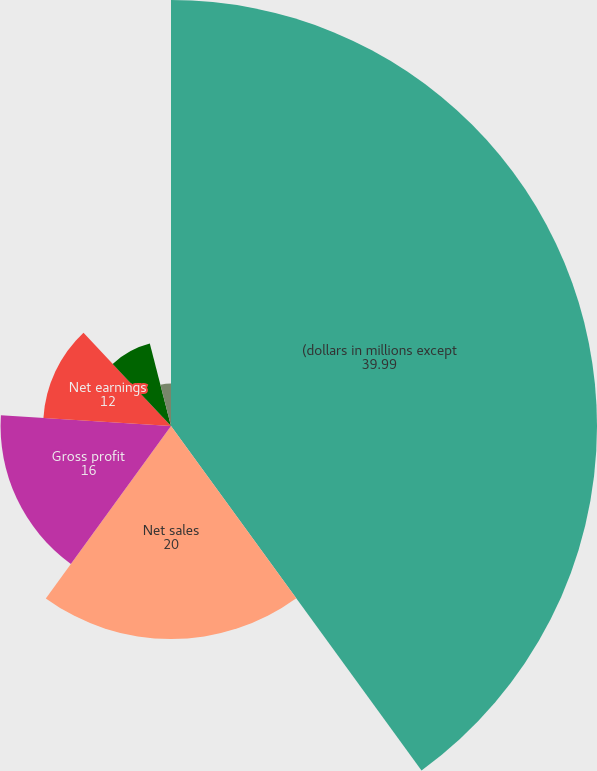Convert chart to OTSL. <chart><loc_0><loc_0><loc_500><loc_500><pie_chart><fcel>(dollars in millions except<fcel>Net sales<fcel>Gross profit<fcel>Net earnings<fcel>Basic<fcel>Diluted<fcel>Common dividends declared<nl><fcel>39.99%<fcel>20.0%<fcel>16.0%<fcel>12.0%<fcel>8.0%<fcel>4.0%<fcel>0.0%<nl></chart> 